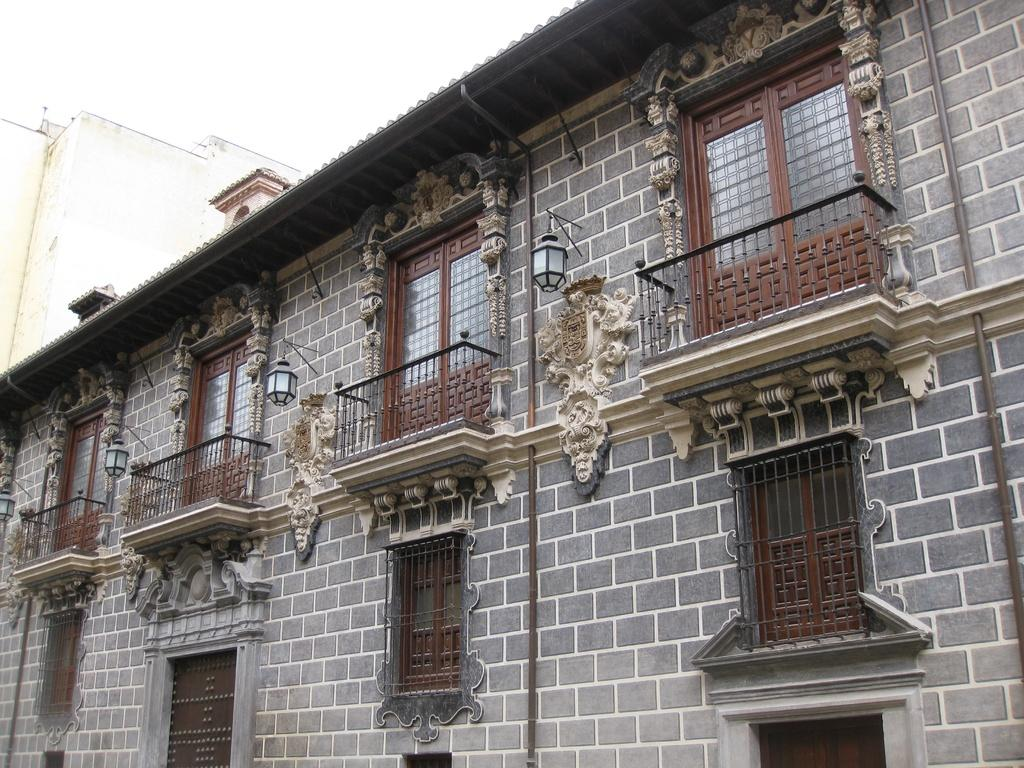What type of structure is present in the image? There is a building in the image. How many doors are visible on the building? The building has four doors. What feature is present in front of each door? There is a balcony in front of each door. How many windows can be seen on the building? The building has three windows. What material is used for the roof of the building? The roof of the building is made up of cement sheet. Can you tell me the color of the sister's leg in the image? There is no mention of a sister or a leg in the image; the focus is on the building and its features. 